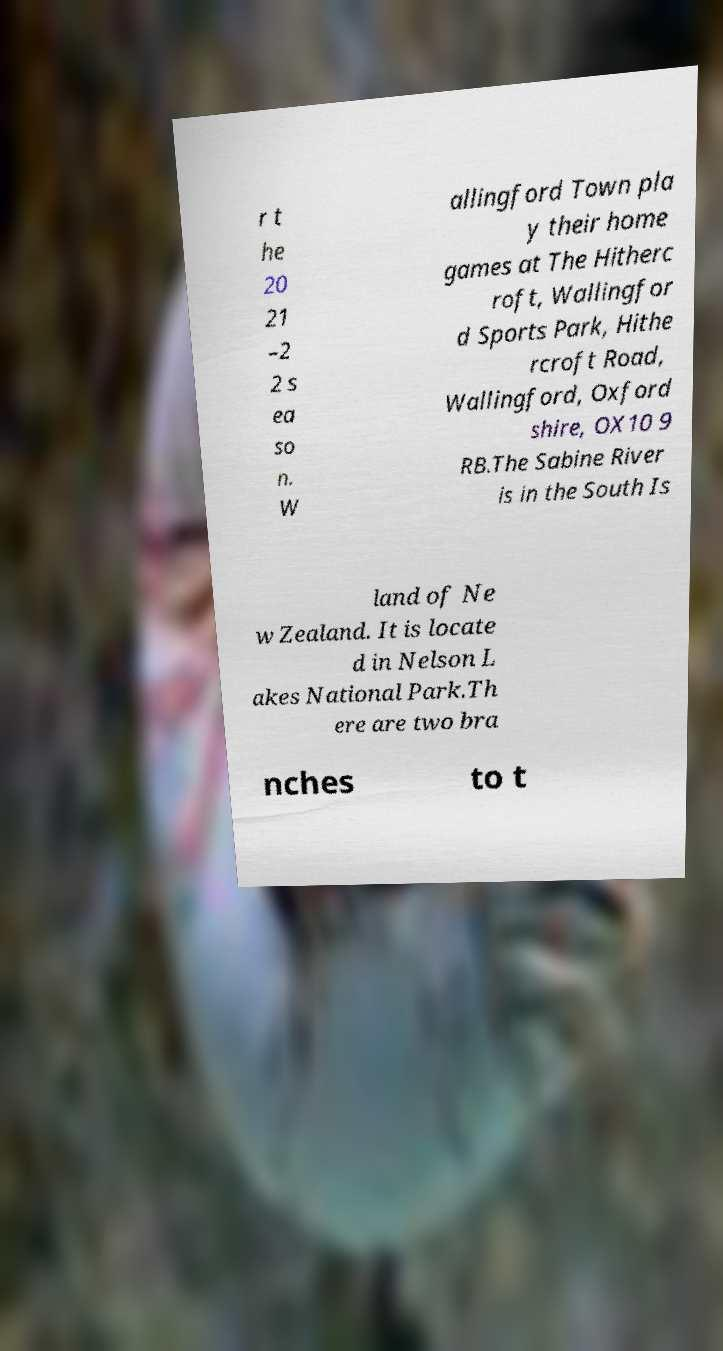Could you extract and type out the text from this image? r t he 20 21 –2 2 s ea so n. W allingford Town pla y their home games at The Hitherc roft, Wallingfor d Sports Park, Hithe rcroft Road, Wallingford, Oxford shire, OX10 9 RB.The Sabine River is in the South Is land of Ne w Zealand. It is locate d in Nelson L akes National Park.Th ere are two bra nches to t 